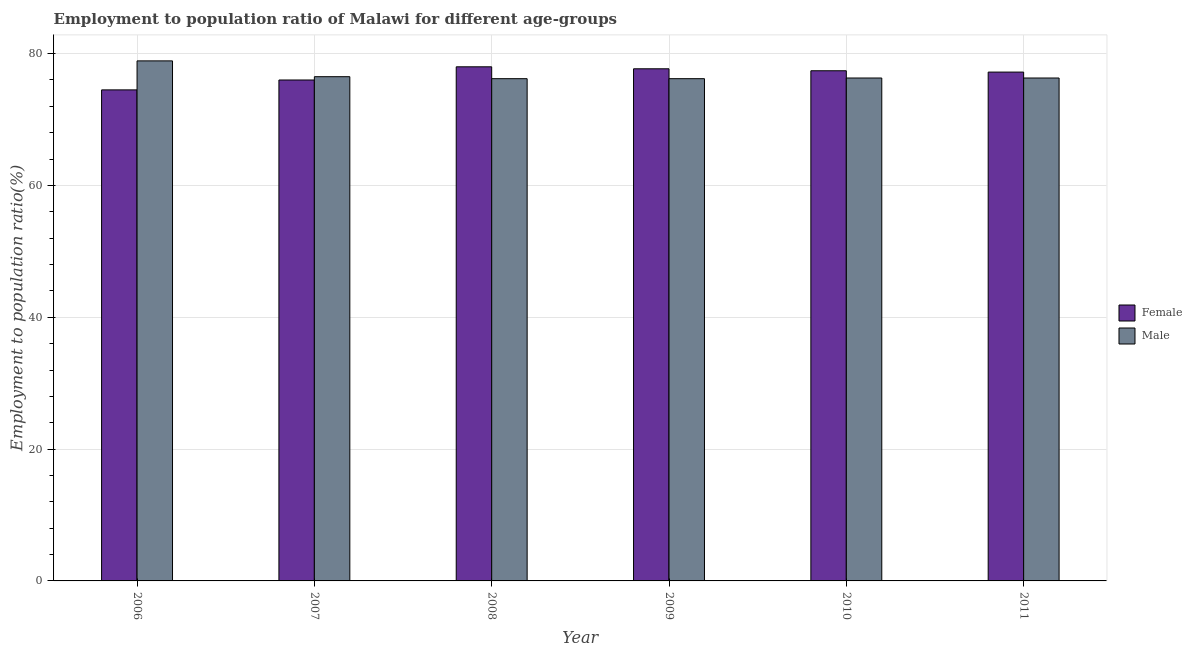How many different coloured bars are there?
Provide a succinct answer. 2. How many groups of bars are there?
Provide a succinct answer. 6. Are the number of bars per tick equal to the number of legend labels?
Your answer should be very brief. Yes. Are the number of bars on each tick of the X-axis equal?
Offer a terse response. Yes. How many bars are there on the 6th tick from the left?
Your answer should be very brief. 2. Across all years, what is the maximum employment to population ratio(female)?
Provide a short and direct response. 78. Across all years, what is the minimum employment to population ratio(female)?
Your answer should be very brief. 74.5. What is the total employment to population ratio(female) in the graph?
Provide a short and direct response. 460.8. What is the difference between the employment to population ratio(male) in 2009 and that in 2010?
Give a very brief answer. -0.1. What is the difference between the employment to population ratio(female) in 2008 and the employment to population ratio(male) in 2007?
Provide a succinct answer. 2. What is the average employment to population ratio(male) per year?
Offer a very short reply. 76.73. In the year 2008, what is the difference between the employment to population ratio(female) and employment to population ratio(male)?
Your answer should be compact. 0. In how many years, is the employment to population ratio(female) greater than 8 %?
Your answer should be compact. 6. What is the ratio of the employment to population ratio(female) in 2007 to that in 2010?
Offer a terse response. 0.98. What is the difference between the highest and the second highest employment to population ratio(male)?
Provide a short and direct response. 2.4. What is the difference between the highest and the lowest employment to population ratio(male)?
Give a very brief answer. 2.7. What does the 2nd bar from the right in 2009 represents?
Your response must be concise. Female. How many bars are there?
Offer a terse response. 12. How many years are there in the graph?
Provide a succinct answer. 6. What is the difference between two consecutive major ticks on the Y-axis?
Your response must be concise. 20. Are the values on the major ticks of Y-axis written in scientific E-notation?
Your answer should be very brief. No. What is the title of the graph?
Your answer should be very brief. Employment to population ratio of Malawi for different age-groups. What is the label or title of the Y-axis?
Keep it short and to the point. Employment to population ratio(%). What is the Employment to population ratio(%) of Female in 2006?
Keep it short and to the point. 74.5. What is the Employment to population ratio(%) of Male in 2006?
Provide a succinct answer. 78.9. What is the Employment to population ratio(%) of Male in 2007?
Your answer should be compact. 76.5. What is the Employment to population ratio(%) of Female in 2008?
Ensure brevity in your answer.  78. What is the Employment to population ratio(%) of Male in 2008?
Give a very brief answer. 76.2. What is the Employment to population ratio(%) of Female in 2009?
Make the answer very short. 77.7. What is the Employment to population ratio(%) of Male in 2009?
Offer a terse response. 76.2. What is the Employment to population ratio(%) of Female in 2010?
Offer a terse response. 77.4. What is the Employment to population ratio(%) of Male in 2010?
Offer a terse response. 76.3. What is the Employment to population ratio(%) in Female in 2011?
Keep it short and to the point. 77.2. What is the Employment to population ratio(%) of Male in 2011?
Your answer should be very brief. 76.3. Across all years, what is the maximum Employment to population ratio(%) in Male?
Give a very brief answer. 78.9. Across all years, what is the minimum Employment to population ratio(%) in Female?
Provide a succinct answer. 74.5. Across all years, what is the minimum Employment to population ratio(%) of Male?
Offer a very short reply. 76.2. What is the total Employment to population ratio(%) of Female in the graph?
Your answer should be compact. 460.8. What is the total Employment to population ratio(%) in Male in the graph?
Provide a succinct answer. 460.4. What is the difference between the Employment to population ratio(%) in Female in 2006 and that in 2007?
Your answer should be very brief. -1.5. What is the difference between the Employment to population ratio(%) in Female in 2006 and that in 2009?
Provide a short and direct response. -3.2. What is the difference between the Employment to population ratio(%) of Female in 2006 and that in 2010?
Keep it short and to the point. -2.9. What is the difference between the Employment to population ratio(%) in Male in 2006 and that in 2010?
Provide a succinct answer. 2.6. What is the difference between the Employment to population ratio(%) in Female in 2006 and that in 2011?
Keep it short and to the point. -2.7. What is the difference between the Employment to population ratio(%) in Male in 2006 and that in 2011?
Your answer should be very brief. 2.6. What is the difference between the Employment to population ratio(%) of Female in 2007 and that in 2009?
Ensure brevity in your answer.  -1.7. What is the difference between the Employment to population ratio(%) in Male in 2007 and that in 2009?
Make the answer very short. 0.3. What is the difference between the Employment to population ratio(%) in Male in 2007 and that in 2011?
Give a very brief answer. 0.2. What is the difference between the Employment to population ratio(%) of Female in 2008 and that in 2010?
Give a very brief answer. 0.6. What is the difference between the Employment to population ratio(%) of Female in 2008 and that in 2011?
Provide a succinct answer. 0.8. What is the difference between the Employment to population ratio(%) of Male in 2008 and that in 2011?
Offer a very short reply. -0.1. What is the difference between the Employment to population ratio(%) in Female in 2009 and that in 2011?
Give a very brief answer. 0.5. What is the difference between the Employment to population ratio(%) of Male in 2009 and that in 2011?
Provide a succinct answer. -0.1. What is the difference between the Employment to population ratio(%) in Female in 2006 and the Employment to population ratio(%) in Male in 2007?
Give a very brief answer. -2. What is the difference between the Employment to population ratio(%) in Female in 2006 and the Employment to population ratio(%) in Male in 2008?
Your response must be concise. -1.7. What is the difference between the Employment to population ratio(%) in Female in 2006 and the Employment to population ratio(%) in Male in 2010?
Provide a succinct answer. -1.8. What is the difference between the Employment to population ratio(%) of Female in 2007 and the Employment to population ratio(%) of Male in 2008?
Offer a very short reply. -0.2. What is the difference between the Employment to population ratio(%) in Female in 2007 and the Employment to population ratio(%) in Male in 2010?
Provide a short and direct response. -0.3. What is the difference between the Employment to population ratio(%) in Female in 2008 and the Employment to population ratio(%) in Male in 2009?
Your response must be concise. 1.8. What is the difference between the Employment to population ratio(%) in Female in 2008 and the Employment to population ratio(%) in Male in 2010?
Your answer should be compact. 1.7. What is the difference between the Employment to population ratio(%) of Female in 2008 and the Employment to population ratio(%) of Male in 2011?
Offer a terse response. 1.7. What is the difference between the Employment to population ratio(%) in Female in 2009 and the Employment to population ratio(%) in Male in 2010?
Provide a short and direct response. 1.4. What is the difference between the Employment to population ratio(%) of Female in 2009 and the Employment to population ratio(%) of Male in 2011?
Your answer should be very brief. 1.4. What is the average Employment to population ratio(%) in Female per year?
Provide a succinct answer. 76.8. What is the average Employment to population ratio(%) in Male per year?
Ensure brevity in your answer.  76.73. In the year 2006, what is the difference between the Employment to population ratio(%) in Female and Employment to population ratio(%) in Male?
Your answer should be very brief. -4.4. In the year 2009, what is the difference between the Employment to population ratio(%) of Female and Employment to population ratio(%) of Male?
Your response must be concise. 1.5. In the year 2011, what is the difference between the Employment to population ratio(%) in Female and Employment to population ratio(%) in Male?
Your response must be concise. 0.9. What is the ratio of the Employment to population ratio(%) of Female in 2006 to that in 2007?
Give a very brief answer. 0.98. What is the ratio of the Employment to population ratio(%) of Male in 2006 to that in 2007?
Offer a terse response. 1.03. What is the ratio of the Employment to population ratio(%) in Female in 2006 to that in 2008?
Provide a short and direct response. 0.96. What is the ratio of the Employment to population ratio(%) of Male in 2006 to that in 2008?
Your answer should be compact. 1.04. What is the ratio of the Employment to population ratio(%) of Female in 2006 to that in 2009?
Provide a succinct answer. 0.96. What is the ratio of the Employment to population ratio(%) of Male in 2006 to that in 2009?
Provide a succinct answer. 1.04. What is the ratio of the Employment to population ratio(%) in Female in 2006 to that in 2010?
Ensure brevity in your answer.  0.96. What is the ratio of the Employment to population ratio(%) in Male in 2006 to that in 2010?
Offer a very short reply. 1.03. What is the ratio of the Employment to population ratio(%) of Female in 2006 to that in 2011?
Offer a terse response. 0.96. What is the ratio of the Employment to population ratio(%) in Male in 2006 to that in 2011?
Keep it short and to the point. 1.03. What is the ratio of the Employment to population ratio(%) in Female in 2007 to that in 2008?
Make the answer very short. 0.97. What is the ratio of the Employment to population ratio(%) in Male in 2007 to that in 2008?
Offer a terse response. 1. What is the ratio of the Employment to population ratio(%) of Female in 2007 to that in 2009?
Your answer should be compact. 0.98. What is the ratio of the Employment to population ratio(%) in Male in 2007 to that in 2009?
Your response must be concise. 1. What is the ratio of the Employment to population ratio(%) of Female in 2007 to that in 2010?
Offer a very short reply. 0.98. What is the ratio of the Employment to population ratio(%) in Female in 2007 to that in 2011?
Ensure brevity in your answer.  0.98. What is the ratio of the Employment to population ratio(%) of Male in 2008 to that in 2010?
Your answer should be compact. 1. What is the ratio of the Employment to population ratio(%) of Female in 2008 to that in 2011?
Keep it short and to the point. 1.01. What is the ratio of the Employment to population ratio(%) in Female in 2009 to that in 2010?
Your answer should be compact. 1. What is the ratio of the Employment to population ratio(%) of Male in 2009 to that in 2010?
Offer a very short reply. 1. What is the difference between the highest and the second highest Employment to population ratio(%) of Female?
Provide a short and direct response. 0.3. What is the difference between the highest and the second highest Employment to population ratio(%) of Male?
Make the answer very short. 2.4. What is the difference between the highest and the lowest Employment to population ratio(%) of Female?
Provide a succinct answer. 3.5. 